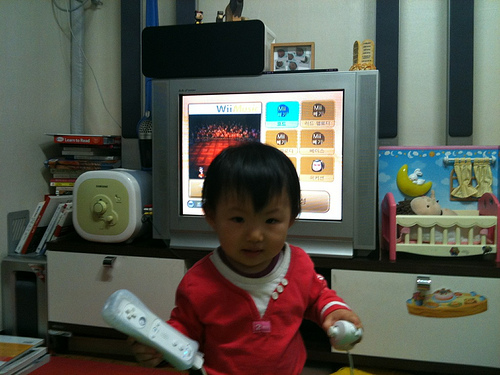<image>What is the name of one of the books? I don't know the exact name of the books, but it could be 'little red riding hood', 'joy of fishing', 'wii for dummies', 'learn to read', or 'dr seuss'. What is the name of one of the books? I don't know the name of one of the books. 